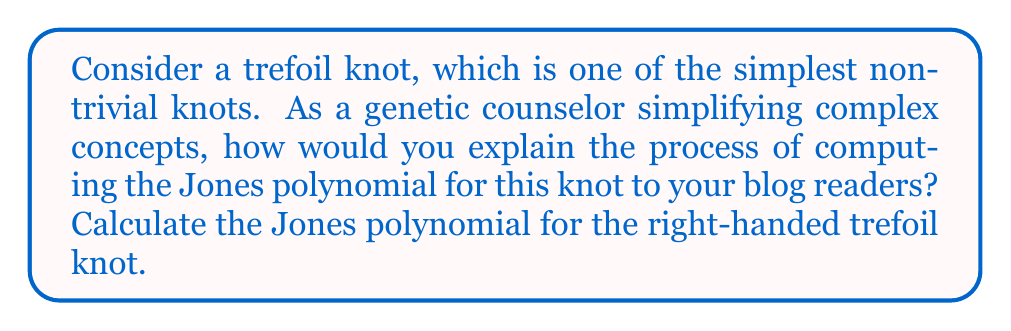Show me your answer to this math problem. To compute the Jones polynomial for the right-handed trefoil knot, we'll follow these steps:

1. First, we need to create a diagram of the right-handed trefoil knot. It has three crossings, all positive.

2. We use the Kauffman bracket polynomial as an intermediate step. The Kauffman bracket is defined by the following skein relations:

   $$\langle \crossover \rangle = A\langle \smoothera \rangle + A^{-1}\langle \smootherb \rangle$$
   $$\langle O \cup K \rangle = (-A^2 - A^{-2})\langle K \rangle$$
   $$\langle O \rangle = 1$$

   Where $\crossover$ represents a crossing, $\smoothera$ and $\smootherb$ are the two ways to smooth the crossing, $O$ is a simple closed curve, and $K$ is any knot or link diagram.

3. Apply these relations to the trefoil knot. We get:

   $$\langle \text{trefoil} \rangle = A\langle \smoothera \rangle + A^{-1}\langle \smootherb \rangle$$

   The $\smoothera$ term leads to a simple closed curve, while the $\smootherb$ term leads to another crossing that we need to resolve.

4. Continuing this process for all crossings, we end up with:

   $$\langle \text{trefoil} \rangle = A^3(-A^2-A^{-2}) + A(-A^2-A^{-2}) + A^{-3}$$

5. Simplify:

   $$\langle \text{trefoil} \rangle = -A^5 - A^{-3} - A^{-7}$$

6. To get the Jones polynomial, we need to apply a normalization factor and substitute $t^{-1/4}$ for $A$:

   $$V_{\text{trefoil}}(t) = (-A^{-3})^{-3w(L)}(-A^5 - A^{-3} - A^{-7})|_{A=t^{-1/4}}$$

   Where $w(L)$ is the writhe of the knot, which for the right-handed trefoil is +3.

7. Substitute and simplify:

   $$V_{\text{trefoil}}(t) = (-t^{1/4})^{-9}(-t^{-5/4} - t^{3/4} - t^{7/4})$$
   $$= t + t^3 - t^4$$

This polynomial uniquely identifies the trefoil knot among all knots.
Answer: $V_{\text{trefoil}}(t) = t + t^3 - t^4$ 